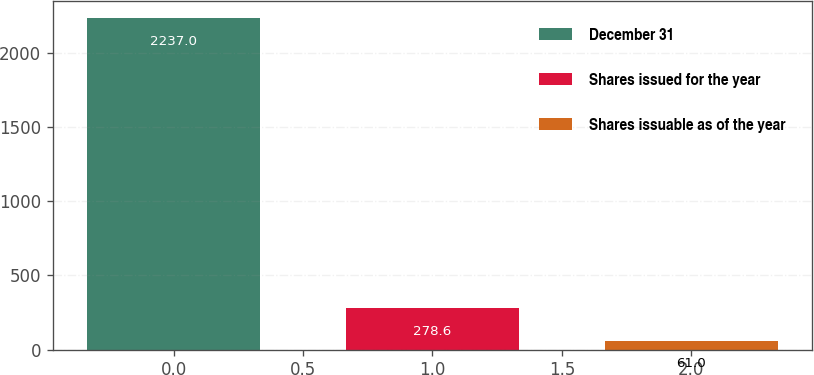Convert chart. <chart><loc_0><loc_0><loc_500><loc_500><bar_chart><fcel>December 31<fcel>Shares issued for the year<fcel>Shares issuable as of the year<nl><fcel>2237<fcel>278.6<fcel>61<nl></chart> 